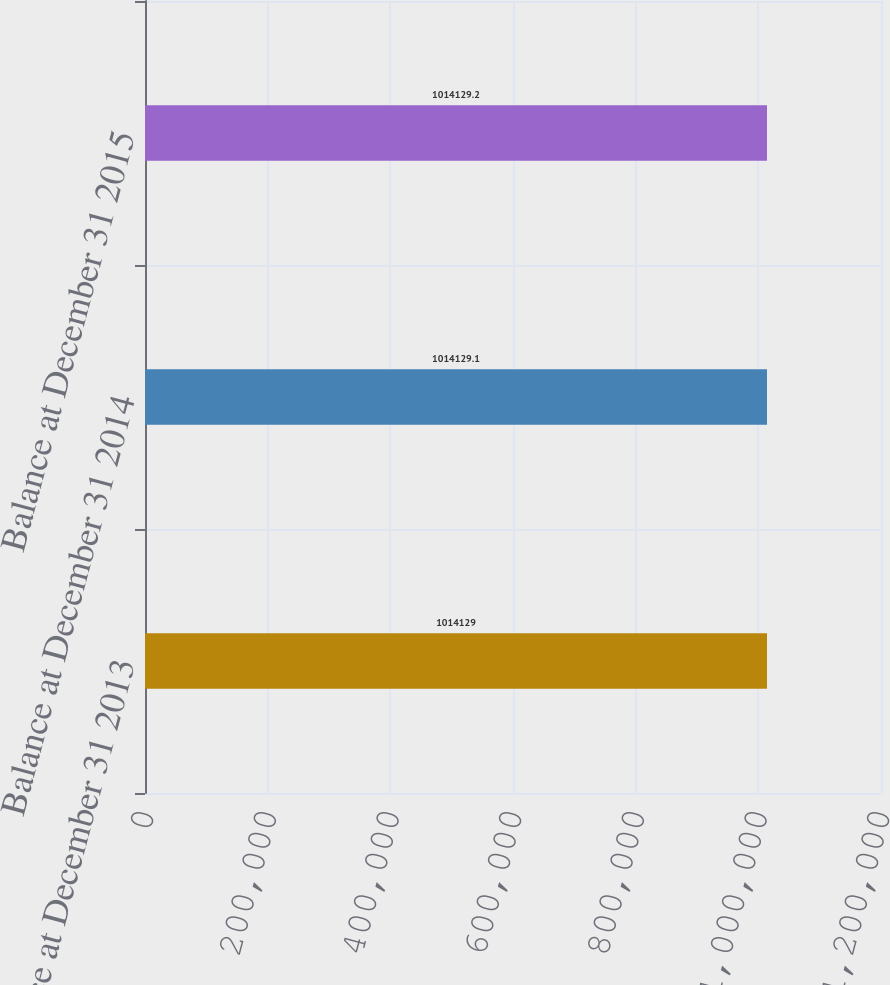<chart> <loc_0><loc_0><loc_500><loc_500><bar_chart><fcel>Balance at December 31 2013<fcel>Balance at December 31 2014<fcel>Balance at December 31 2015<nl><fcel>1.01413e+06<fcel>1.01413e+06<fcel>1.01413e+06<nl></chart> 